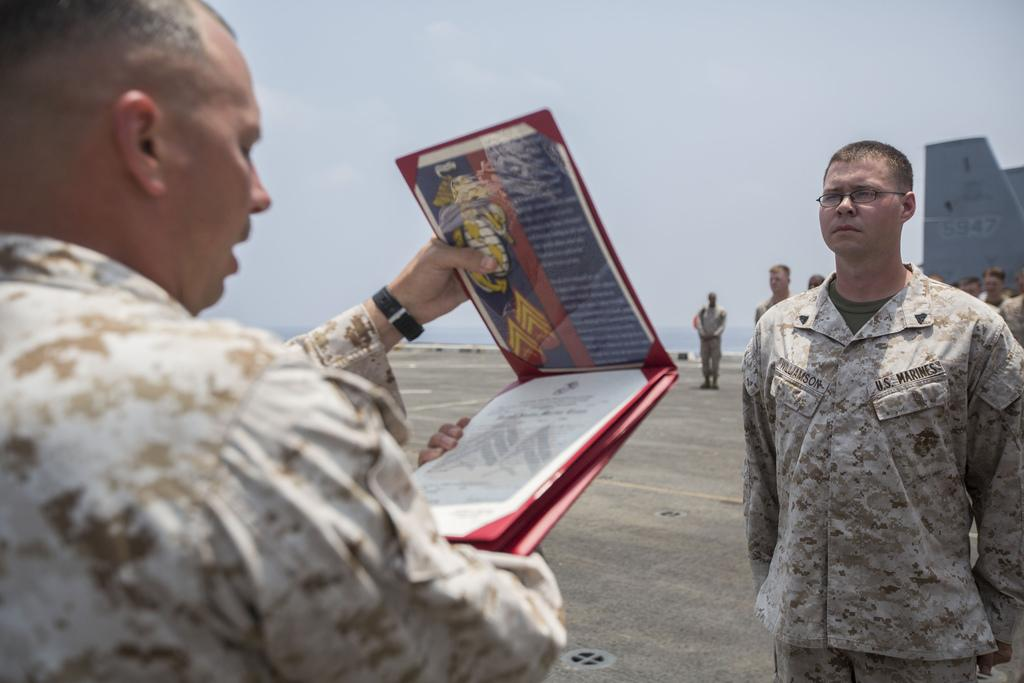How many people are present in the image? There are two persons standing in the image. What is one of the persons holding? There is a person holding a book in the image. Can you describe the background of the image? There is a group of people standing in the background, along with water and sky visible. What type of copper material can be seen in the image? There is no copper material present in the image. What day of the week is depicted in the image? The day of the week is not visible or mentioned in the image. --- Facts: 1. There is a person sitting on a chair in the image. 2. The person is holding a laptop. 3. There is a desk in front of the person. 4. There are books on the desk. 5. There is a window visible in the background of the image. Absurd Topics: dance, ocean, birdhouse Conversation: What is the person in the image doing? The person is sitting on a chair in the image. What object is the person holding? The person is holding a laptop. What is in front of the person? There is a desk in front of the person. What can be seen on the desk? There are books on the desk. What is visible in the background of the image? There is a window visible in the background of the image. Reasoning: Let's think step by step in order to produce the conversation. We start by identifying the main subject in the image, which is the person sitting on a chair. Then, we describe what the person is holding, which is a laptop. Next, we expand the conversation to include the desk in front of the person and the books on the desk. Finally, we mention the window visible in the background of the image. Absurd Question/Answer: What type of dance is being performed in the image? There is no dance being performed in the image; the person is sitting and holding a laptop. Can you see a birdhouse in the image? There is no birdhouse present in the image. 